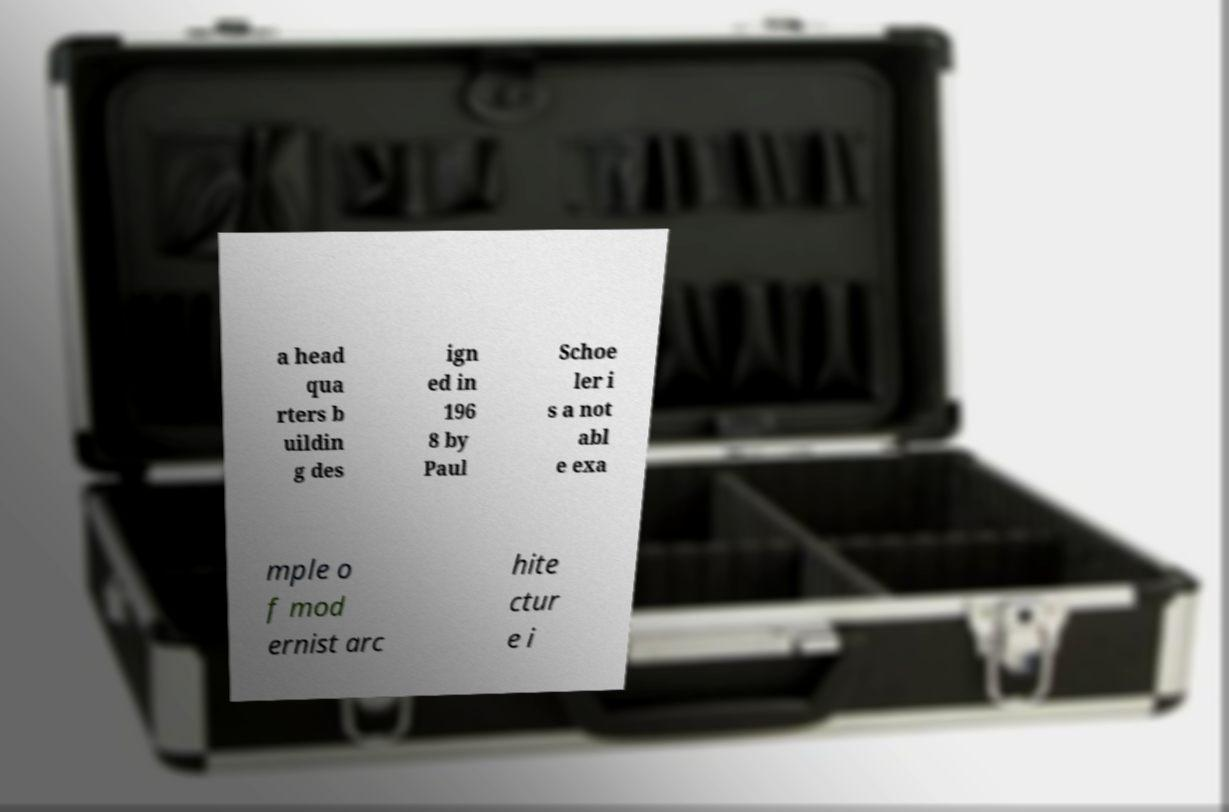Could you assist in decoding the text presented in this image and type it out clearly? a head qua rters b uildin g des ign ed in 196 8 by Paul Schoe ler i s a not abl e exa mple o f mod ernist arc hite ctur e i 